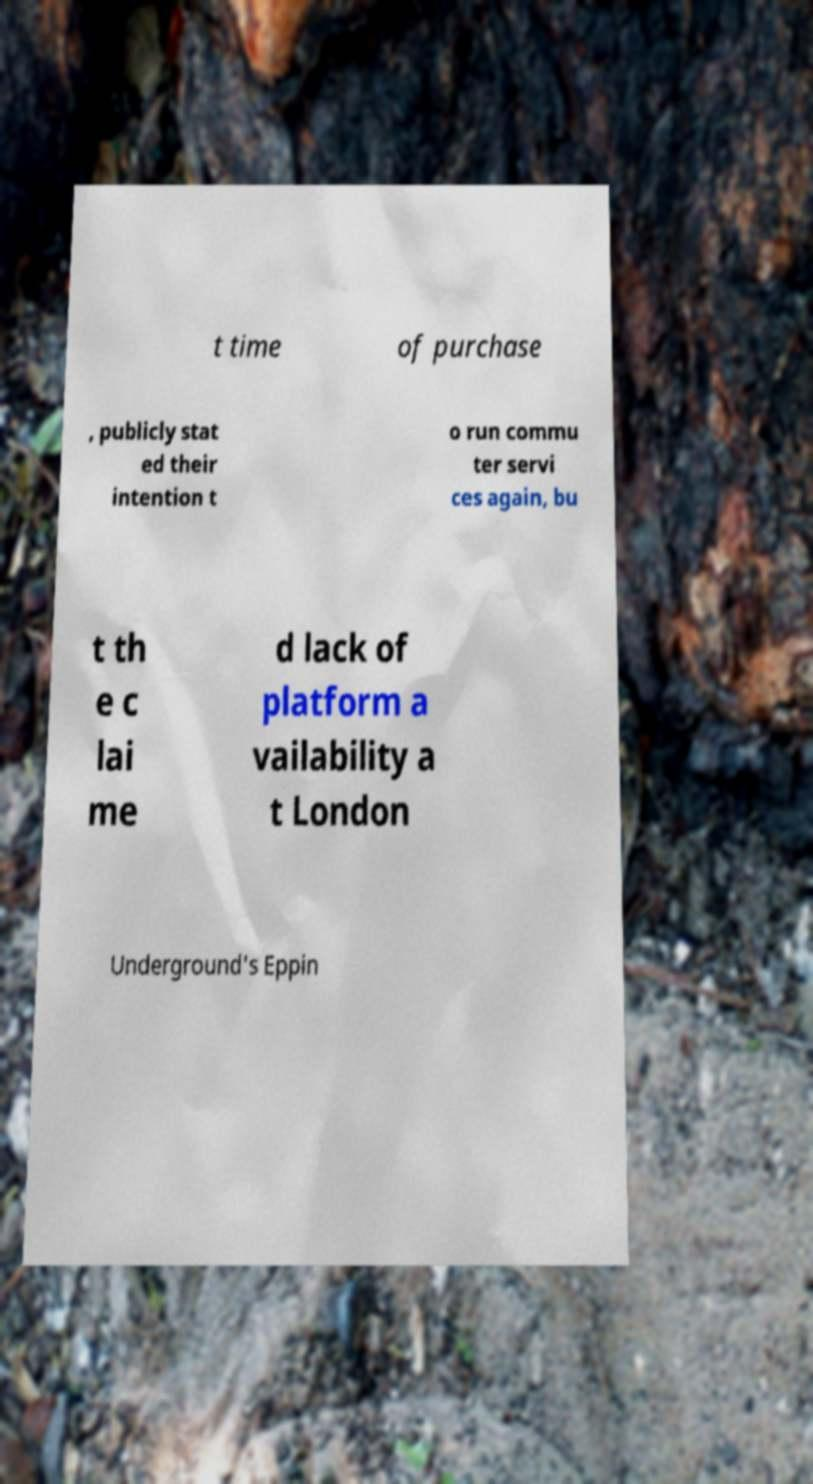Could you assist in decoding the text presented in this image and type it out clearly? t time of purchase , publicly stat ed their intention t o run commu ter servi ces again, bu t th e c lai me d lack of platform a vailability a t London Underground's Eppin 